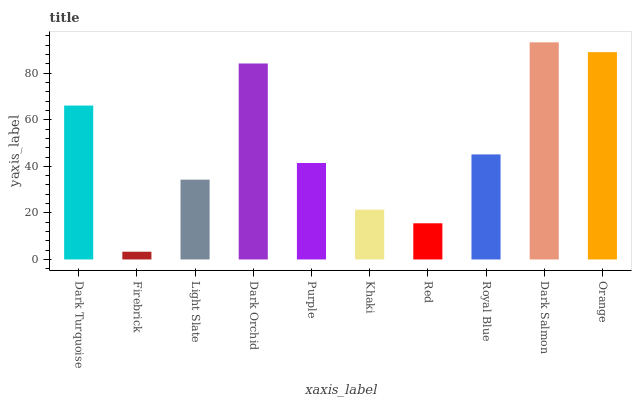Is Firebrick the minimum?
Answer yes or no. Yes. Is Dark Salmon the maximum?
Answer yes or no. Yes. Is Light Slate the minimum?
Answer yes or no. No. Is Light Slate the maximum?
Answer yes or no. No. Is Light Slate greater than Firebrick?
Answer yes or no. Yes. Is Firebrick less than Light Slate?
Answer yes or no. Yes. Is Firebrick greater than Light Slate?
Answer yes or no. No. Is Light Slate less than Firebrick?
Answer yes or no. No. Is Royal Blue the high median?
Answer yes or no. Yes. Is Purple the low median?
Answer yes or no. Yes. Is Orange the high median?
Answer yes or no. No. Is Orange the low median?
Answer yes or no. No. 